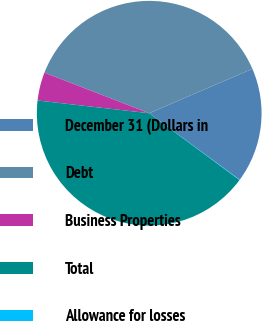<chart> <loc_0><loc_0><loc_500><loc_500><pie_chart><fcel>December 31 (Dollars in<fcel>Debt<fcel>Business Properties<fcel>Total<fcel>Allowance for losses<nl><fcel>16.56%<fcel>37.65%<fcel>4.07%<fcel>41.67%<fcel>0.05%<nl></chart> 